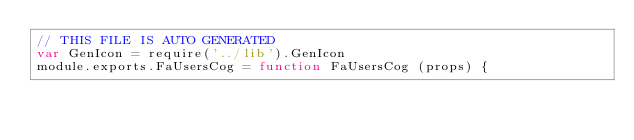<code> <loc_0><loc_0><loc_500><loc_500><_JavaScript_>// THIS FILE IS AUTO GENERATED
var GenIcon = require('../lib').GenIcon
module.exports.FaUsersCog = function FaUsersCog (props) {</code> 